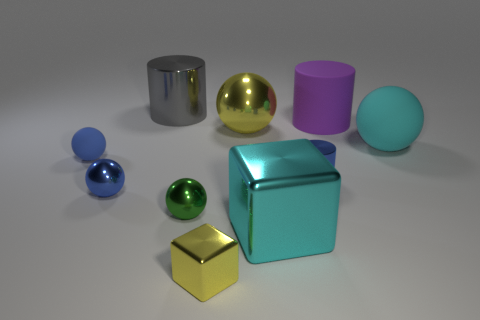What number of things are either gray matte balls or cyan shiny objects?
Provide a succinct answer. 1. Are there any tiny blue shiny objects in front of the big cyan shiny thing?
Provide a short and direct response. No. Is there a tiny blue cylinder that has the same material as the large cyan ball?
Your answer should be very brief. No. What size is the matte ball that is the same color as the large block?
Keep it short and to the point. Large. What number of blocks are either big purple things or large yellow shiny things?
Make the answer very short. 0. Is the number of tiny green balls on the right side of the yellow metal sphere greater than the number of tiny blue rubber objects to the right of the gray cylinder?
Offer a very short reply. No. What number of metallic objects are the same color as the big rubber cylinder?
Provide a succinct answer. 0. The cyan ball that is made of the same material as the purple cylinder is what size?
Your answer should be very brief. Large. How many things are spheres that are right of the tiny green sphere or large brown balls?
Offer a very short reply. 2. There is a big ball that is in front of the large yellow ball; does it have the same color as the tiny metal cylinder?
Keep it short and to the point. No. 